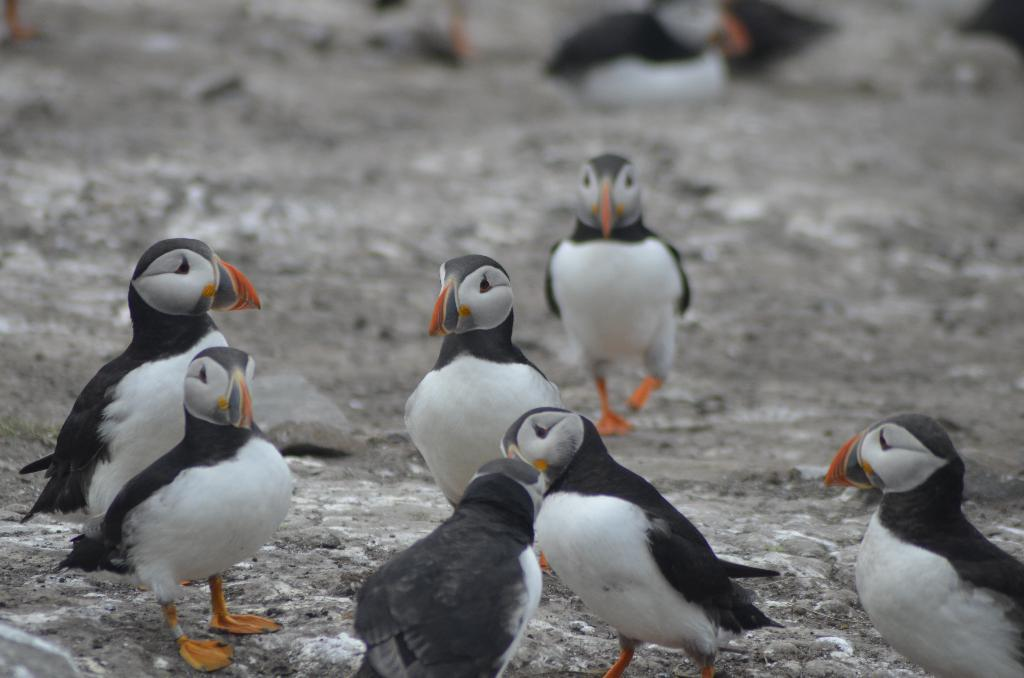What type of animals are in the foreground of the image? There are puffins in the foreground of the image. Where are the puffins located in the image? The puffins are on the ground. Can you see more puffins in the image? Yes, there are puffins in the background of the image. What type of vase is present in the image? There is no vase present in the image; it features puffins on the ground. Is there any indication of a war or conflict in the image? No, there is no indication of a war or conflict in the image; it features puffins on the ground. 